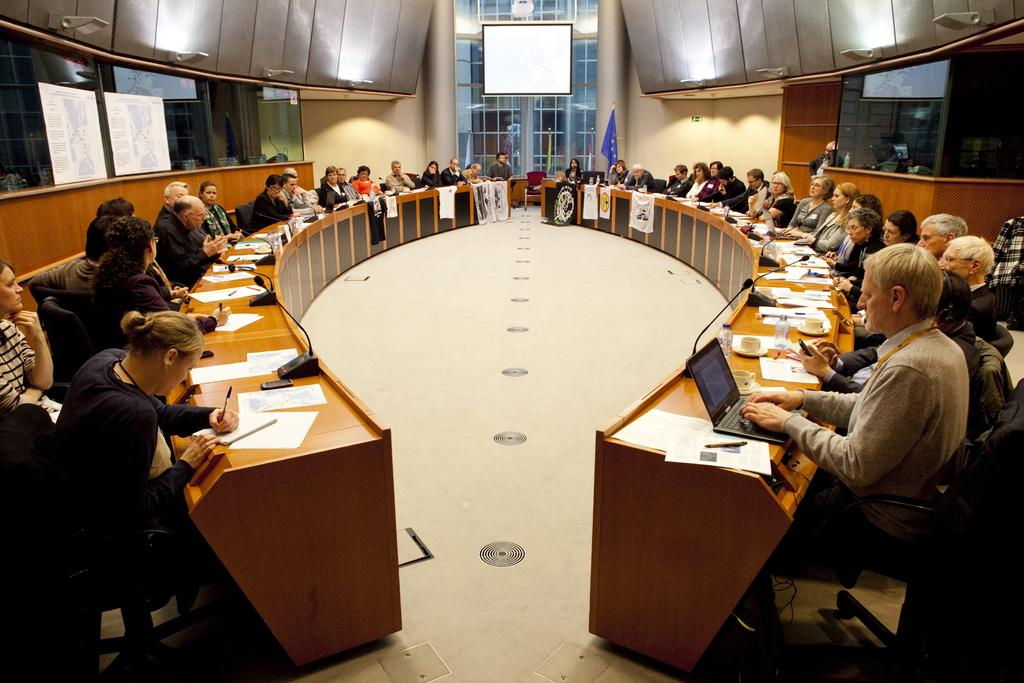How many people are in the image? There is a group of people in the image. What are the people doing in the image? The people are seated on chairs. What objects can be seen on the table in the image? There are laptops, papers, water bottles, and microphones on the table. Can you describe the distribution of the snake in the image? There is no snake present in the image. 